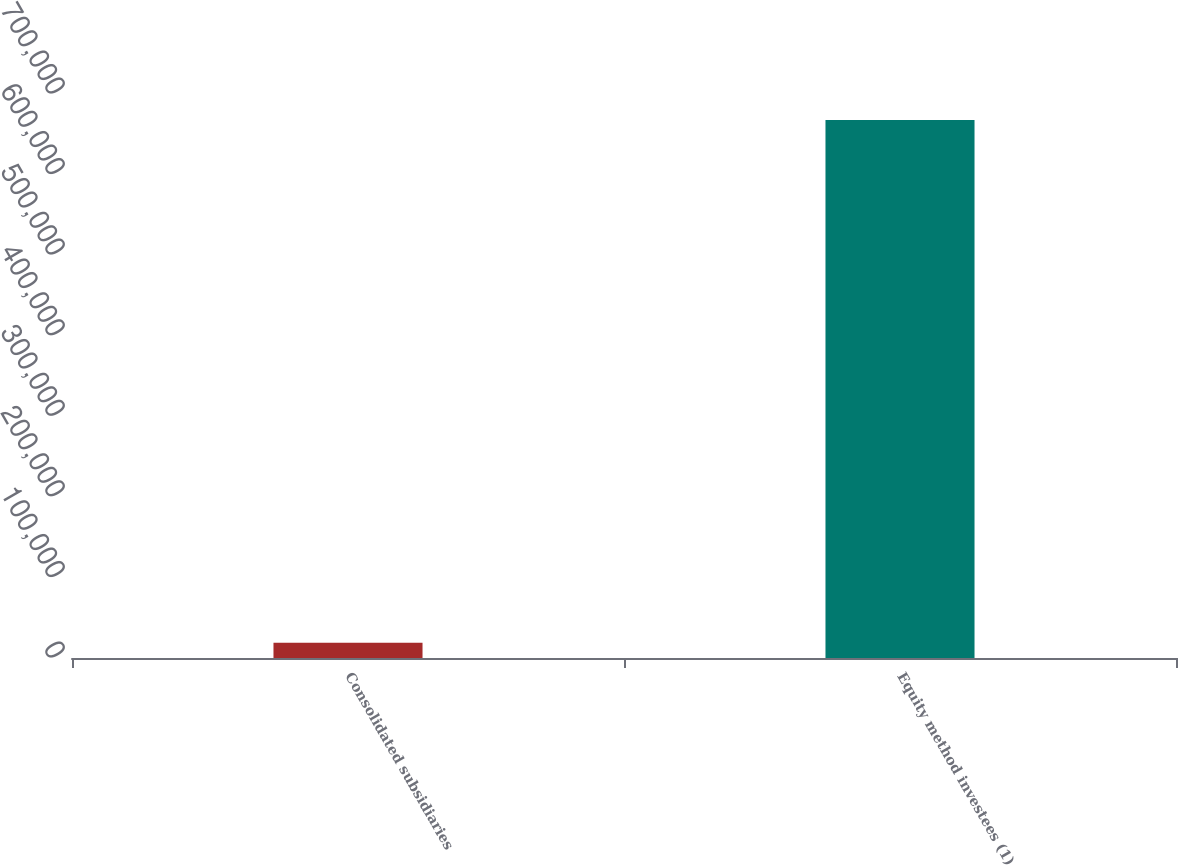<chart> <loc_0><loc_0><loc_500><loc_500><bar_chart><fcel>Consolidated subsidiaries<fcel>Equity method investees (1)<nl><fcel>18882<fcel>667752<nl></chart> 